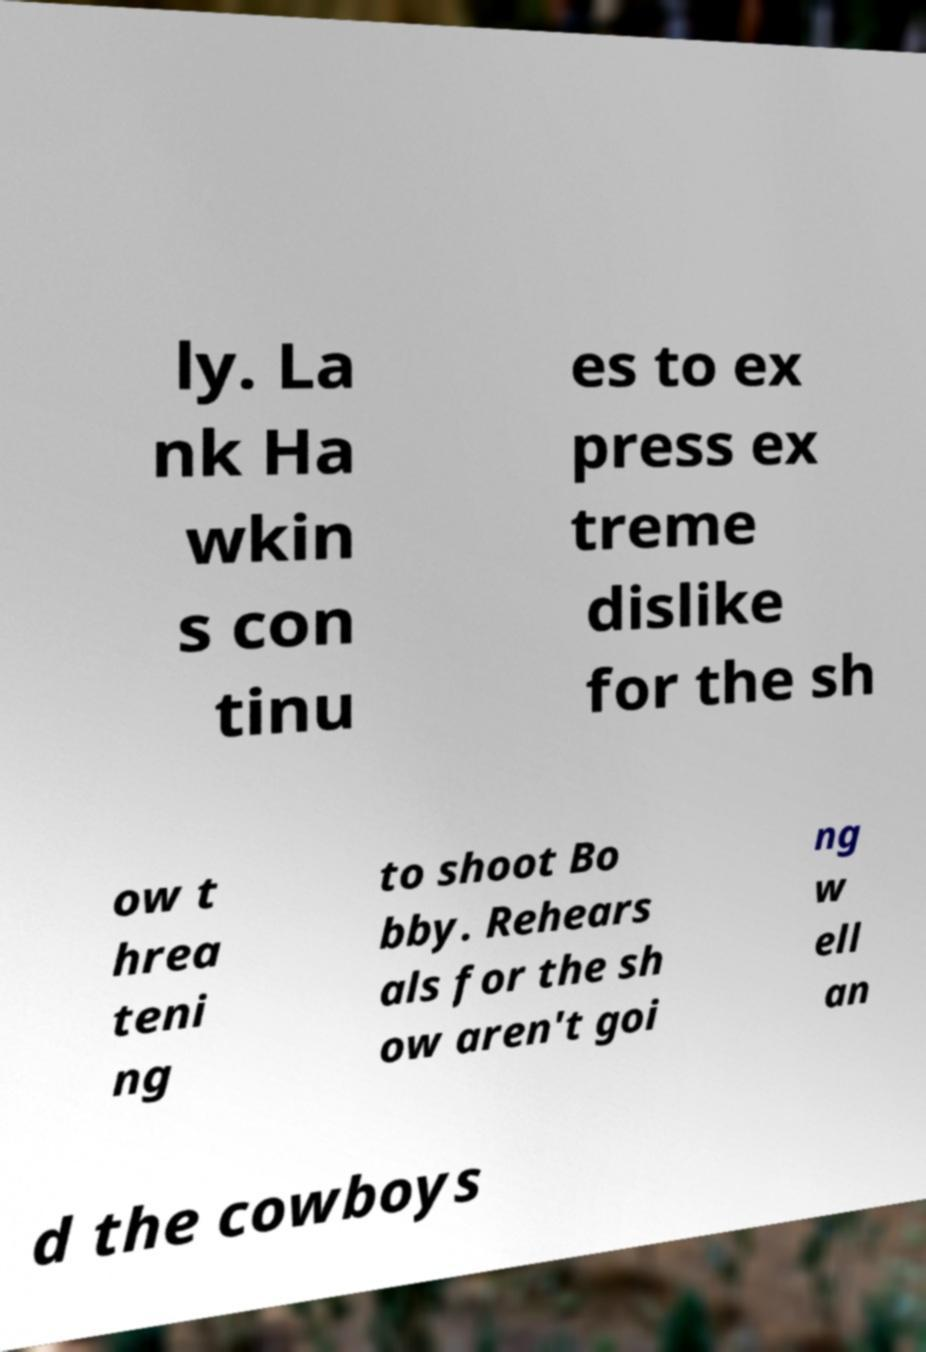There's text embedded in this image that I need extracted. Can you transcribe it verbatim? ly. La nk Ha wkin s con tinu es to ex press ex treme dislike for the sh ow t hrea teni ng to shoot Bo bby. Rehears als for the sh ow aren't goi ng w ell an d the cowboys 